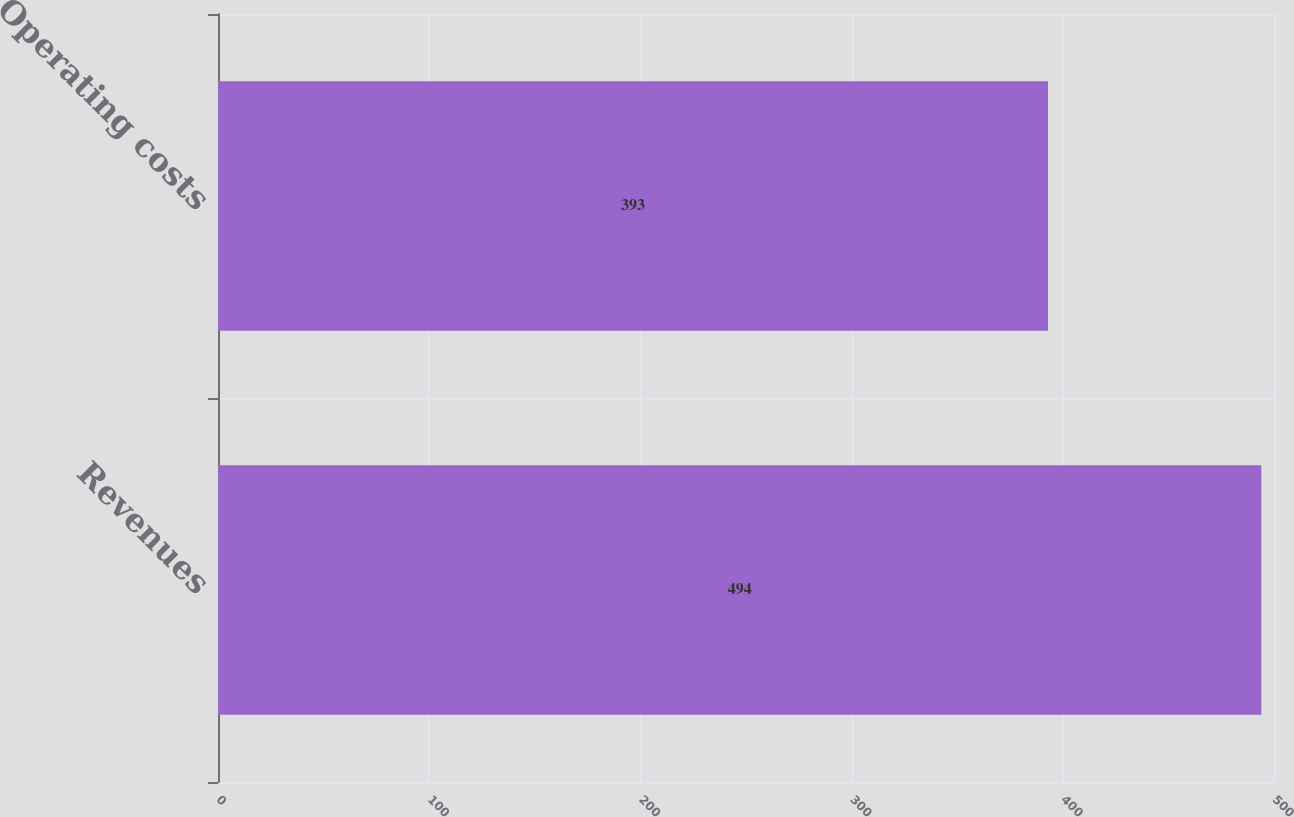Convert chart to OTSL. <chart><loc_0><loc_0><loc_500><loc_500><bar_chart><fcel>Revenues<fcel>Operating costs<nl><fcel>494<fcel>393<nl></chart> 